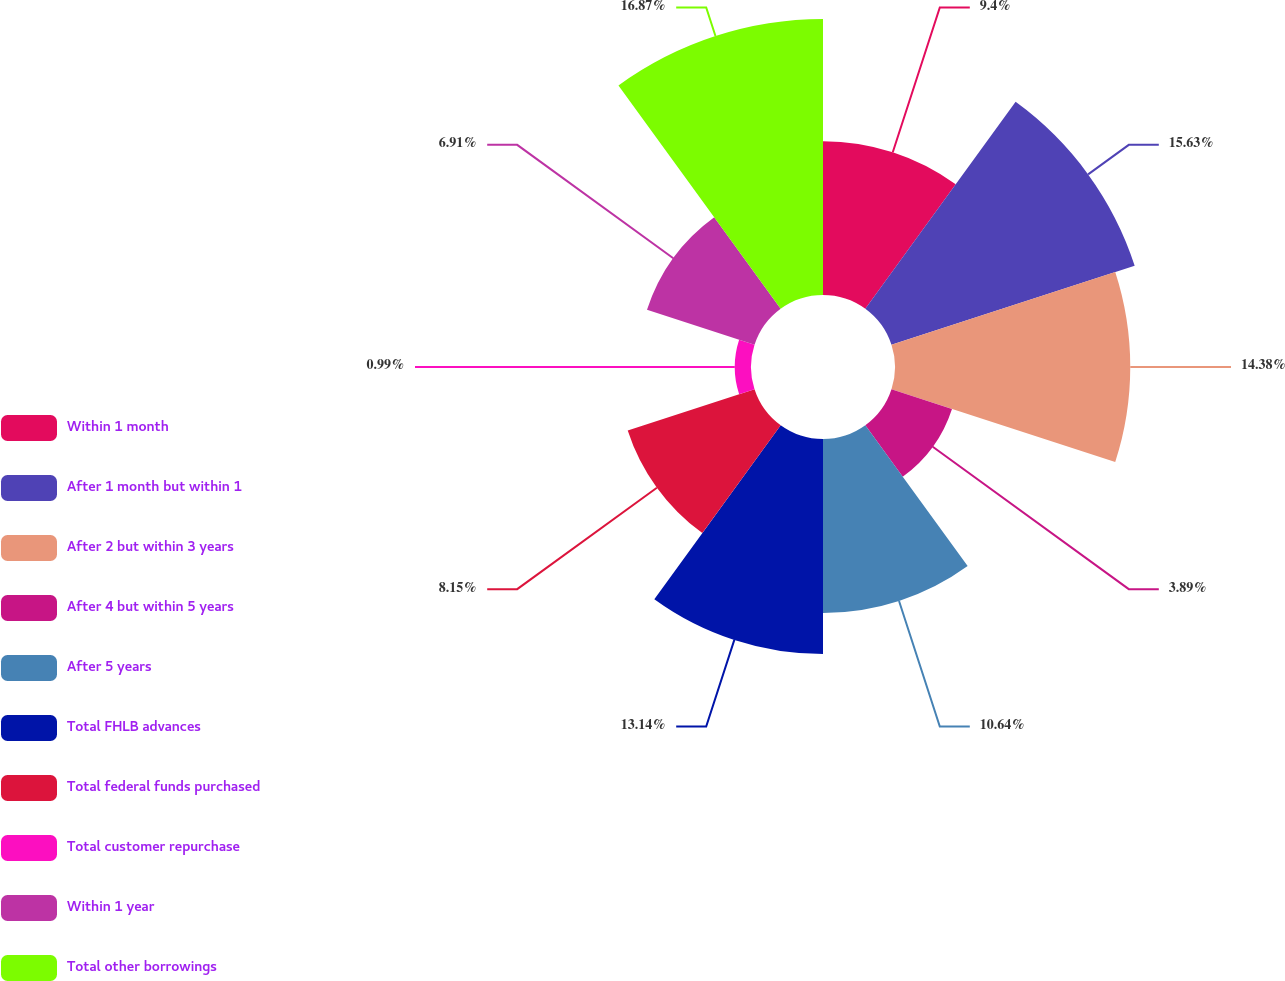Convert chart. <chart><loc_0><loc_0><loc_500><loc_500><pie_chart><fcel>Within 1 month<fcel>After 1 month but within 1<fcel>After 2 but within 3 years<fcel>After 4 but within 5 years<fcel>After 5 years<fcel>Total FHLB advances<fcel>Total federal funds purchased<fcel>Total customer repurchase<fcel>Within 1 year<fcel>Total other borrowings<nl><fcel>9.4%<fcel>15.63%<fcel>14.38%<fcel>3.89%<fcel>10.64%<fcel>13.14%<fcel>8.15%<fcel>0.99%<fcel>6.91%<fcel>16.87%<nl></chart> 